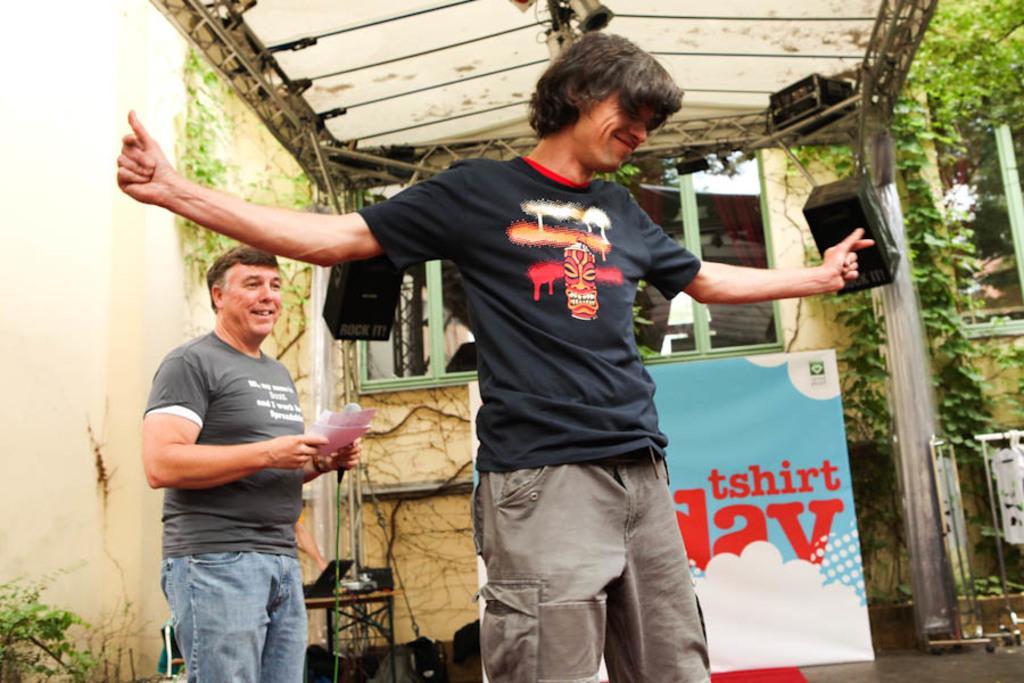How would you summarize this image in a sentence or two? In the middle of this image, there is a person in a black color t-shirt, smiling and stretching his both hands. On the left side, there is a person in a gray color t-shirt, holding a mic with a hand, holding documents with other hand, smiling and standing. In the background, there is a banner, there are speakers attached to the poles, there are other devices attached to the roof, trees, plants, buildings and there is a wall. 